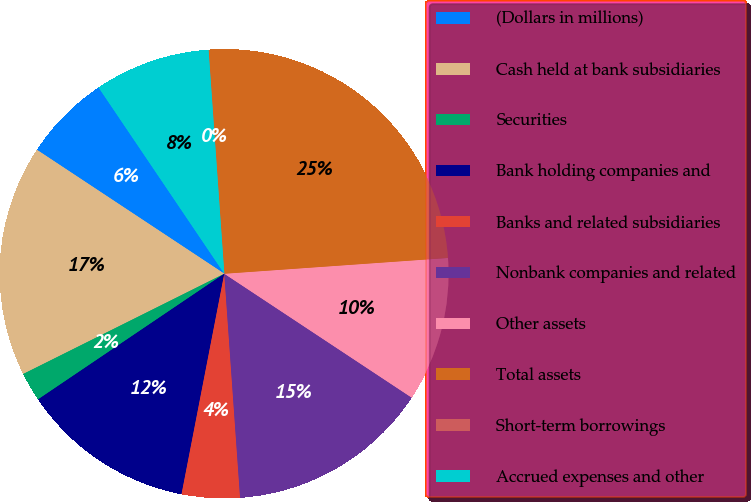Convert chart to OTSL. <chart><loc_0><loc_0><loc_500><loc_500><pie_chart><fcel>(Dollars in millions)<fcel>Cash held at bank subsidiaries<fcel>Securities<fcel>Bank holding companies and<fcel>Banks and related subsidiaries<fcel>Nonbank companies and related<fcel>Other assets<fcel>Total assets<fcel>Short-term borrowings<fcel>Accrued expenses and other<nl><fcel>6.25%<fcel>16.66%<fcel>2.09%<fcel>12.5%<fcel>4.17%<fcel>14.58%<fcel>10.42%<fcel>24.99%<fcel>0.01%<fcel>8.33%<nl></chart> 